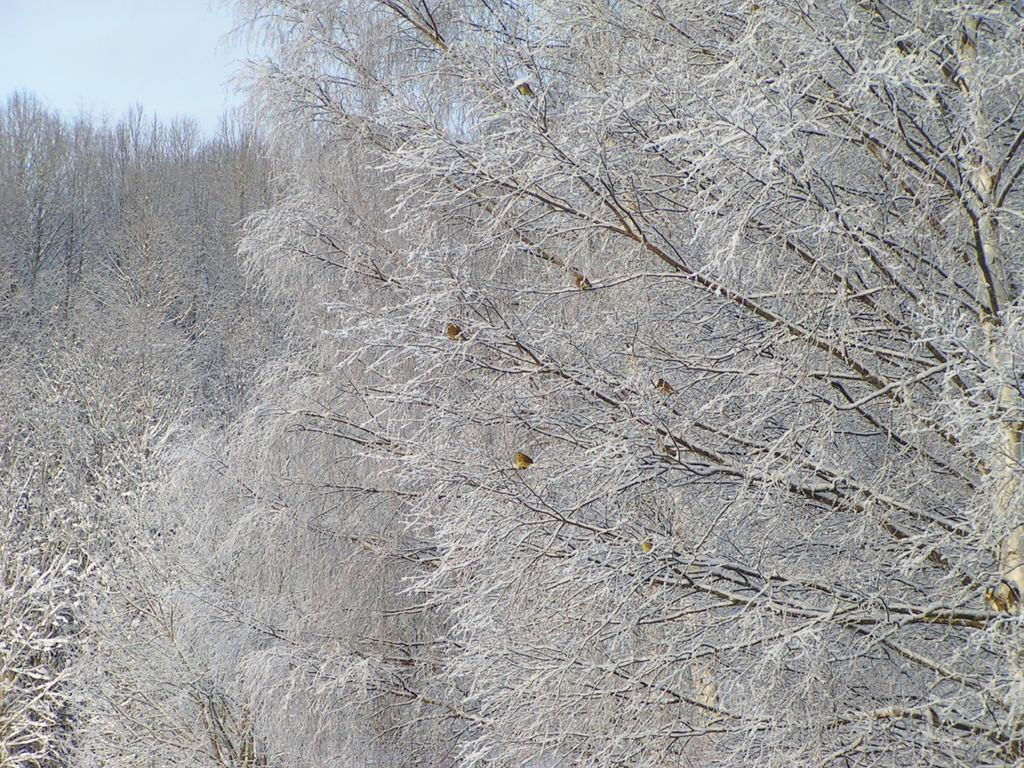What type of vegetation can be seen in the image? There are trees in the image. What creatures are on the trees? Butterflies appear to be on the trees. What can be seen in the background of the image? The sky is visible in the background of the image. What type of dirt can be seen on the butterflies in the image? There is no dirt visible on the butterflies in the image, as they appear to be clean and unobstructed. 